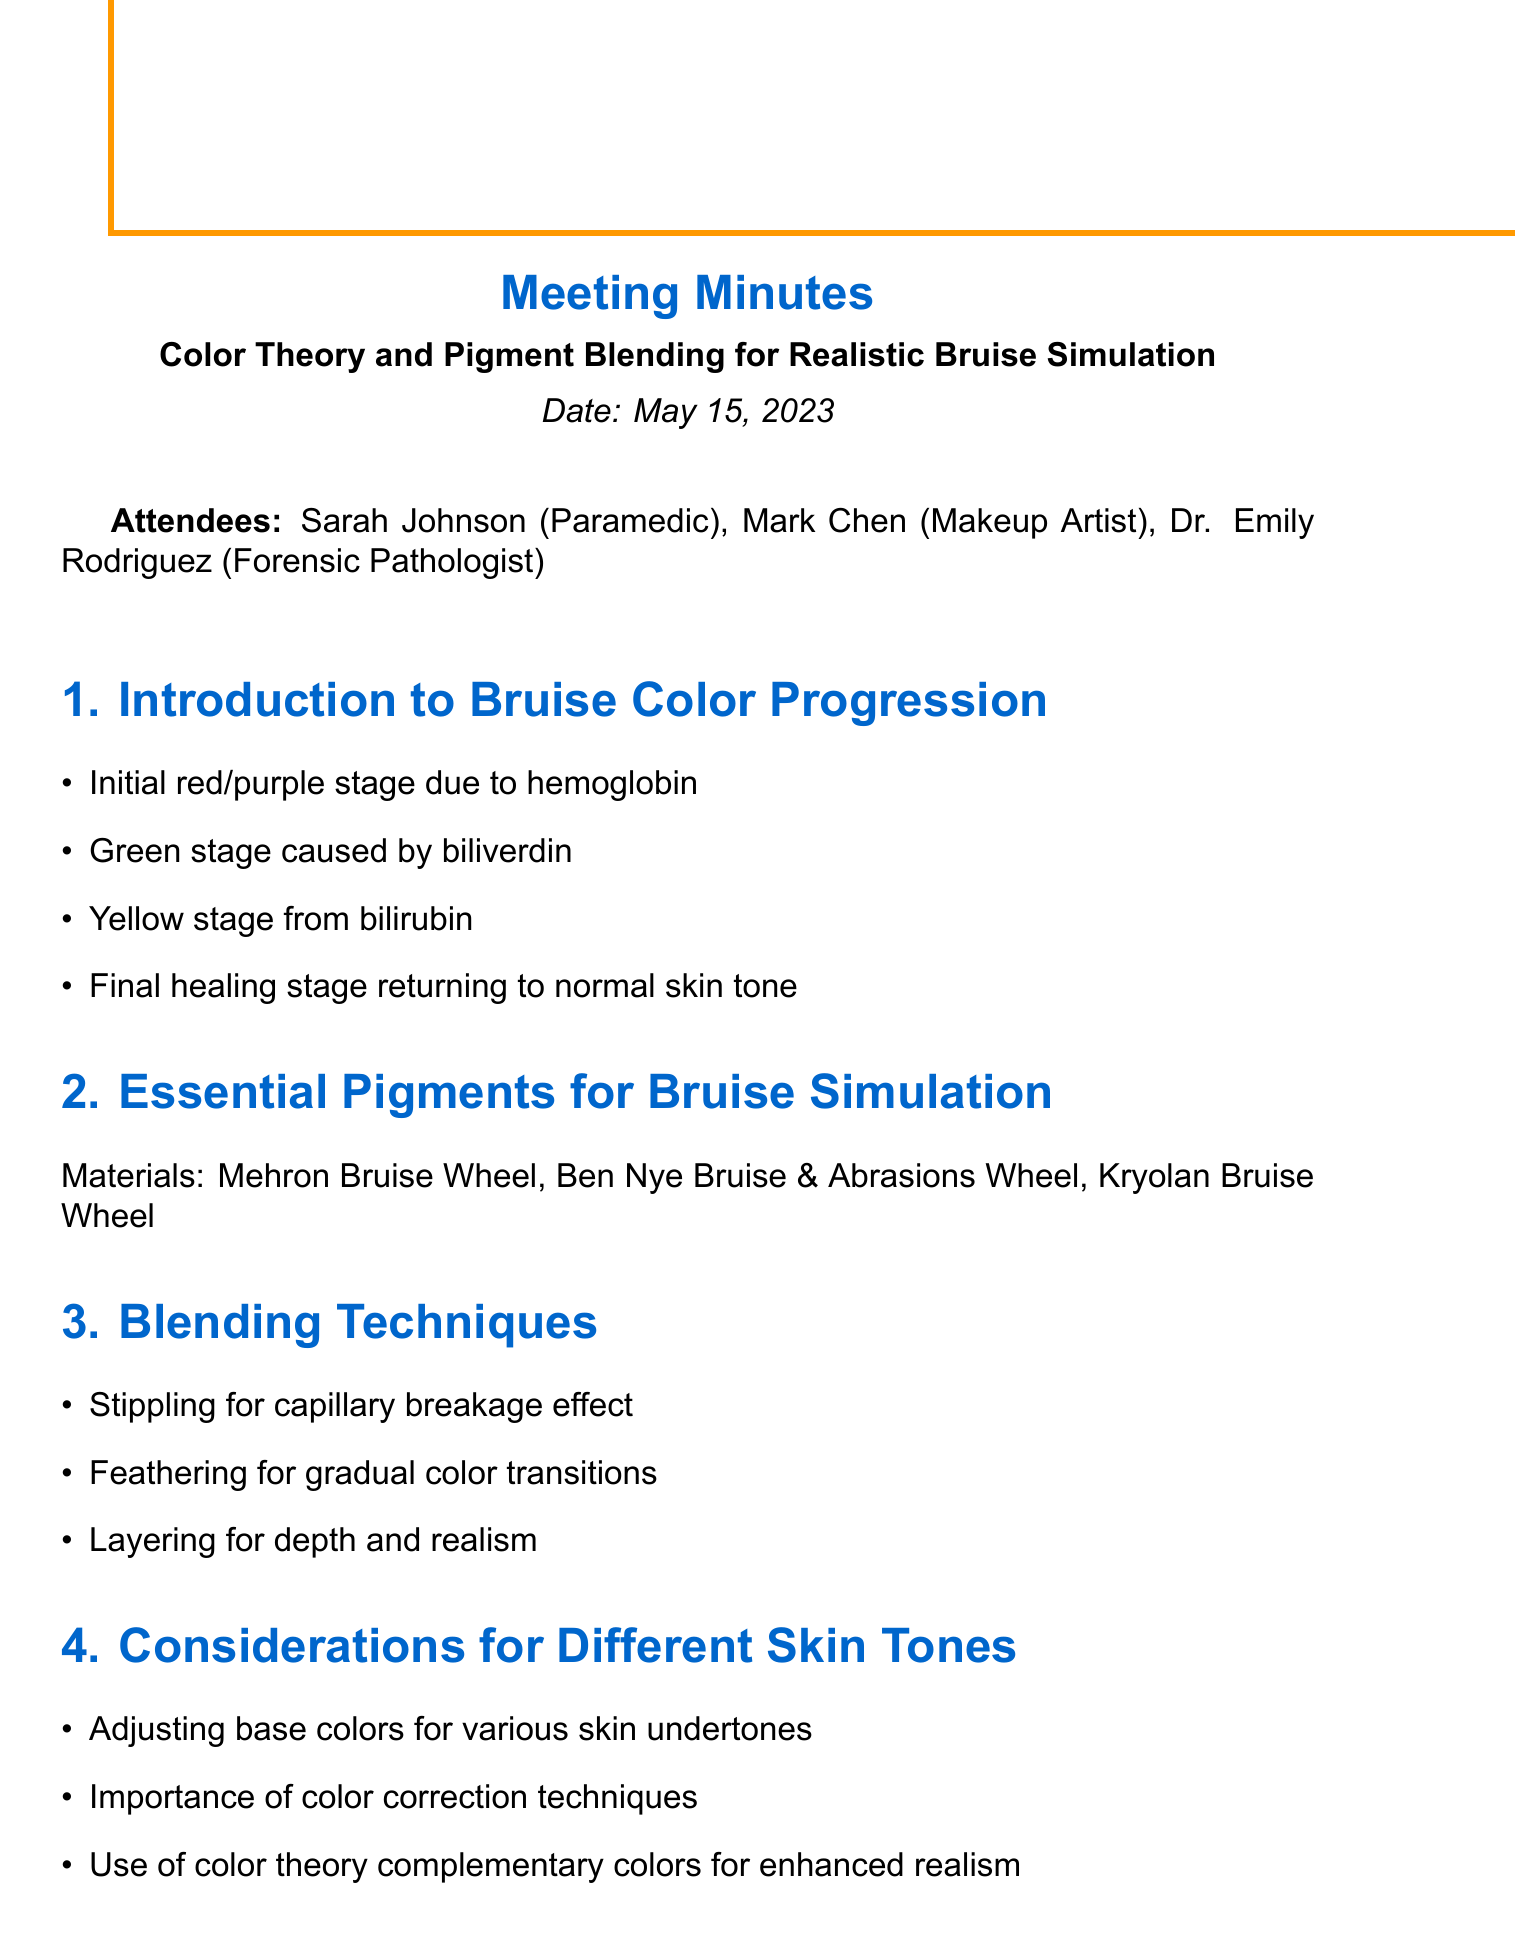What is the meeting title? The meeting title is explicitly stated in the document header.
Answer: Color Theory and Pigment Blending for Realistic Bruise Simulation Who were the attendees? The attendees are listed in a single line in the document.
Answer: Sarah Johnson, Mark Chen, Dr. Emily Rodriguez What is the date of the meeting? The date can be found under the meeting title section in the document.
Answer: May 15, 2023 What is the first stage of bruise color progression? The initial stage is mentioned in the introduction section detailing the bruise progression.
Answer: Initial red/purple stage due to hemoglobin What technique is used for gradual color transitions? This blending technique is specifically noted in the blending techniques section.
Answer: Feathering What is one of the action items mentioned in the next steps? The next steps section lists several action items for follow-up after the meeting.
Answer: Schedule hands-on workshop for paramedic team What materials were mentioned for bruise simulation? The essential materials are stated clearly in the corresponding section.
Answer: Mehron Bruise Wheel, Ben Nye Bruise & Abrasions Wheel, Kryolan Bruise Wheel How many key points are listed under the Introduction to Bruise Color Progression? The number of key points can be counted in the corresponding section of the document.
Answer: Four What is emphasized in the considerations for different skin tones? This section highlights important aspects for applying pigments to various skin types.
Answer: Adjusting base colors for various skin undertones 